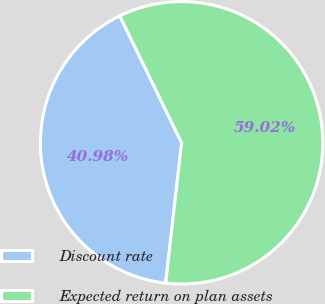Convert chart to OTSL. <chart><loc_0><loc_0><loc_500><loc_500><pie_chart><fcel>Discount rate<fcel>Expected return on plan assets<nl><fcel>40.98%<fcel>59.02%<nl></chart> 